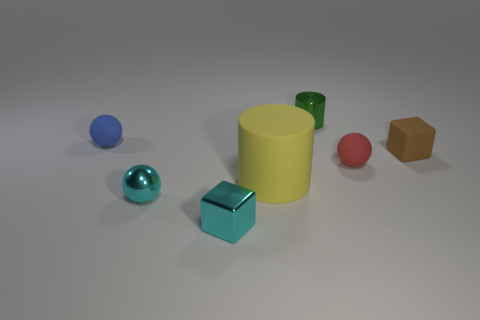What color is the block that is behind the small cyan block?
Ensure brevity in your answer.  Brown. Are there any brown things that are in front of the small rubber ball that is on the right side of the shiny block?
Provide a short and direct response. No. There is a tiny brown thing; is it the same shape as the small rubber thing to the left of the tiny green shiny object?
Give a very brief answer. No. What size is the object that is both behind the small cyan ball and in front of the red rubber sphere?
Offer a very short reply. Large. Is there a tiny cyan sphere made of the same material as the brown thing?
Your answer should be very brief. No. The thing that is the same color as the tiny shiny ball is what size?
Make the answer very short. Small. There is a small cube that is to the right of the small sphere that is right of the green cylinder; what is its material?
Offer a terse response. Rubber. What number of matte blocks are the same color as the tiny shiny block?
Offer a very short reply. 0. What size is the cylinder that is the same material as the small cyan cube?
Your answer should be compact. Small. What shape is the matte object that is on the left side of the large yellow cylinder?
Ensure brevity in your answer.  Sphere. 